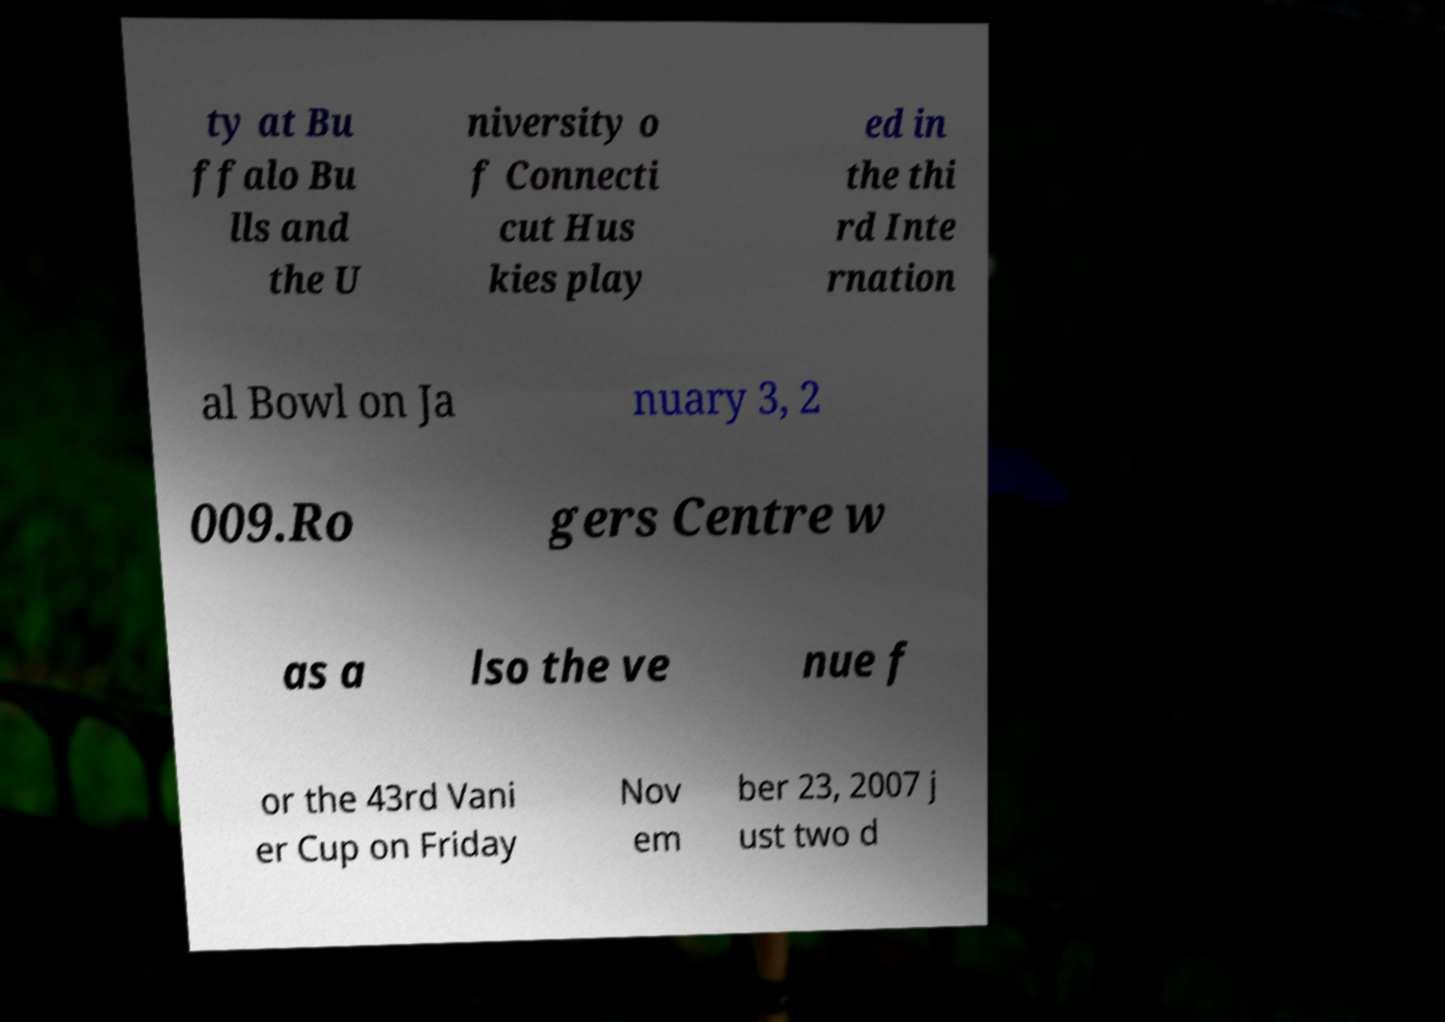Please read and relay the text visible in this image. What does it say? ty at Bu ffalo Bu lls and the U niversity o f Connecti cut Hus kies play ed in the thi rd Inte rnation al Bowl on Ja nuary 3, 2 009.Ro gers Centre w as a lso the ve nue f or the 43rd Vani er Cup on Friday Nov em ber 23, 2007 j ust two d 